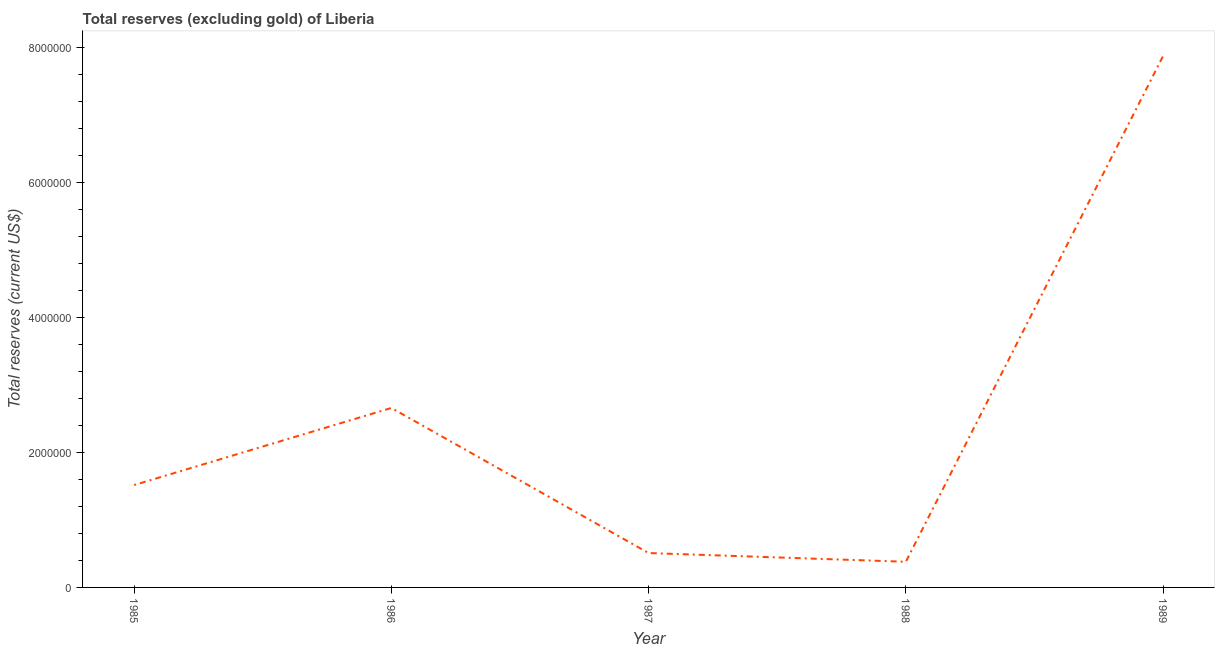What is the total reserves (excluding gold) in 1986?
Make the answer very short. 2.66e+06. Across all years, what is the maximum total reserves (excluding gold)?
Your response must be concise. 7.88e+06. Across all years, what is the minimum total reserves (excluding gold)?
Your answer should be compact. 3.80e+05. In which year was the total reserves (excluding gold) maximum?
Ensure brevity in your answer.  1989. In which year was the total reserves (excluding gold) minimum?
Provide a short and direct response. 1988. What is the sum of the total reserves (excluding gold)?
Give a very brief answer. 1.29e+07. What is the difference between the total reserves (excluding gold) in 1988 and 1989?
Provide a succinct answer. -7.50e+06. What is the average total reserves (excluding gold) per year?
Offer a terse response. 2.59e+06. What is the median total reserves (excluding gold)?
Ensure brevity in your answer.  1.52e+06. What is the ratio of the total reserves (excluding gold) in 1985 to that in 1987?
Your response must be concise. 2.98. Is the difference between the total reserves (excluding gold) in 1986 and 1989 greater than the difference between any two years?
Provide a short and direct response. No. What is the difference between the highest and the second highest total reserves (excluding gold)?
Make the answer very short. 5.22e+06. Is the sum of the total reserves (excluding gold) in 1987 and 1988 greater than the maximum total reserves (excluding gold) across all years?
Offer a terse response. No. What is the difference between the highest and the lowest total reserves (excluding gold)?
Offer a very short reply. 7.50e+06. In how many years, is the total reserves (excluding gold) greater than the average total reserves (excluding gold) taken over all years?
Make the answer very short. 2. How many lines are there?
Your answer should be very brief. 1. What is the difference between two consecutive major ticks on the Y-axis?
Keep it short and to the point. 2.00e+06. Does the graph contain any zero values?
Provide a succinct answer. No. What is the title of the graph?
Your response must be concise. Total reserves (excluding gold) of Liberia. What is the label or title of the Y-axis?
Your answer should be very brief. Total reserves (current US$). What is the Total reserves (current US$) in 1985?
Give a very brief answer. 1.52e+06. What is the Total reserves (current US$) of 1986?
Offer a terse response. 2.66e+06. What is the Total reserves (current US$) in 1987?
Offer a very short reply. 5.10e+05. What is the Total reserves (current US$) in 1988?
Ensure brevity in your answer.  3.80e+05. What is the Total reserves (current US$) of 1989?
Your answer should be very brief. 7.88e+06. What is the difference between the Total reserves (current US$) in 1985 and 1986?
Provide a succinct answer. -1.14e+06. What is the difference between the Total reserves (current US$) in 1985 and 1987?
Ensure brevity in your answer.  1.01e+06. What is the difference between the Total reserves (current US$) in 1985 and 1988?
Give a very brief answer. 1.14e+06. What is the difference between the Total reserves (current US$) in 1985 and 1989?
Offer a terse response. -6.36e+06. What is the difference between the Total reserves (current US$) in 1986 and 1987?
Give a very brief answer. 2.15e+06. What is the difference between the Total reserves (current US$) in 1986 and 1988?
Keep it short and to the point. 2.28e+06. What is the difference between the Total reserves (current US$) in 1986 and 1989?
Keep it short and to the point. -5.22e+06. What is the difference between the Total reserves (current US$) in 1987 and 1988?
Your answer should be compact. 1.29e+05. What is the difference between the Total reserves (current US$) in 1987 and 1989?
Your response must be concise. -7.37e+06. What is the difference between the Total reserves (current US$) in 1988 and 1989?
Provide a short and direct response. -7.50e+06. What is the ratio of the Total reserves (current US$) in 1985 to that in 1986?
Provide a short and direct response. 0.57. What is the ratio of the Total reserves (current US$) in 1985 to that in 1987?
Offer a terse response. 2.98. What is the ratio of the Total reserves (current US$) in 1985 to that in 1988?
Give a very brief answer. 3.99. What is the ratio of the Total reserves (current US$) in 1985 to that in 1989?
Provide a succinct answer. 0.19. What is the ratio of the Total reserves (current US$) in 1986 to that in 1987?
Provide a succinct answer. 5.22. What is the ratio of the Total reserves (current US$) in 1986 to that in 1988?
Keep it short and to the point. 6.99. What is the ratio of the Total reserves (current US$) in 1986 to that in 1989?
Your answer should be very brief. 0.34. What is the ratio of the Total reserves (current US$) in 1987 to that in 1988?
Offer a terse response. 1.34. What is the ratio of the Total reserves (current US$) in 1987 to that in 1989?
Offer a terse response. 0.07. What is the ratio of the Total reserves (current US$) in 1988 to that in 1989?
Ensure brevity in your answer.  0.05. 